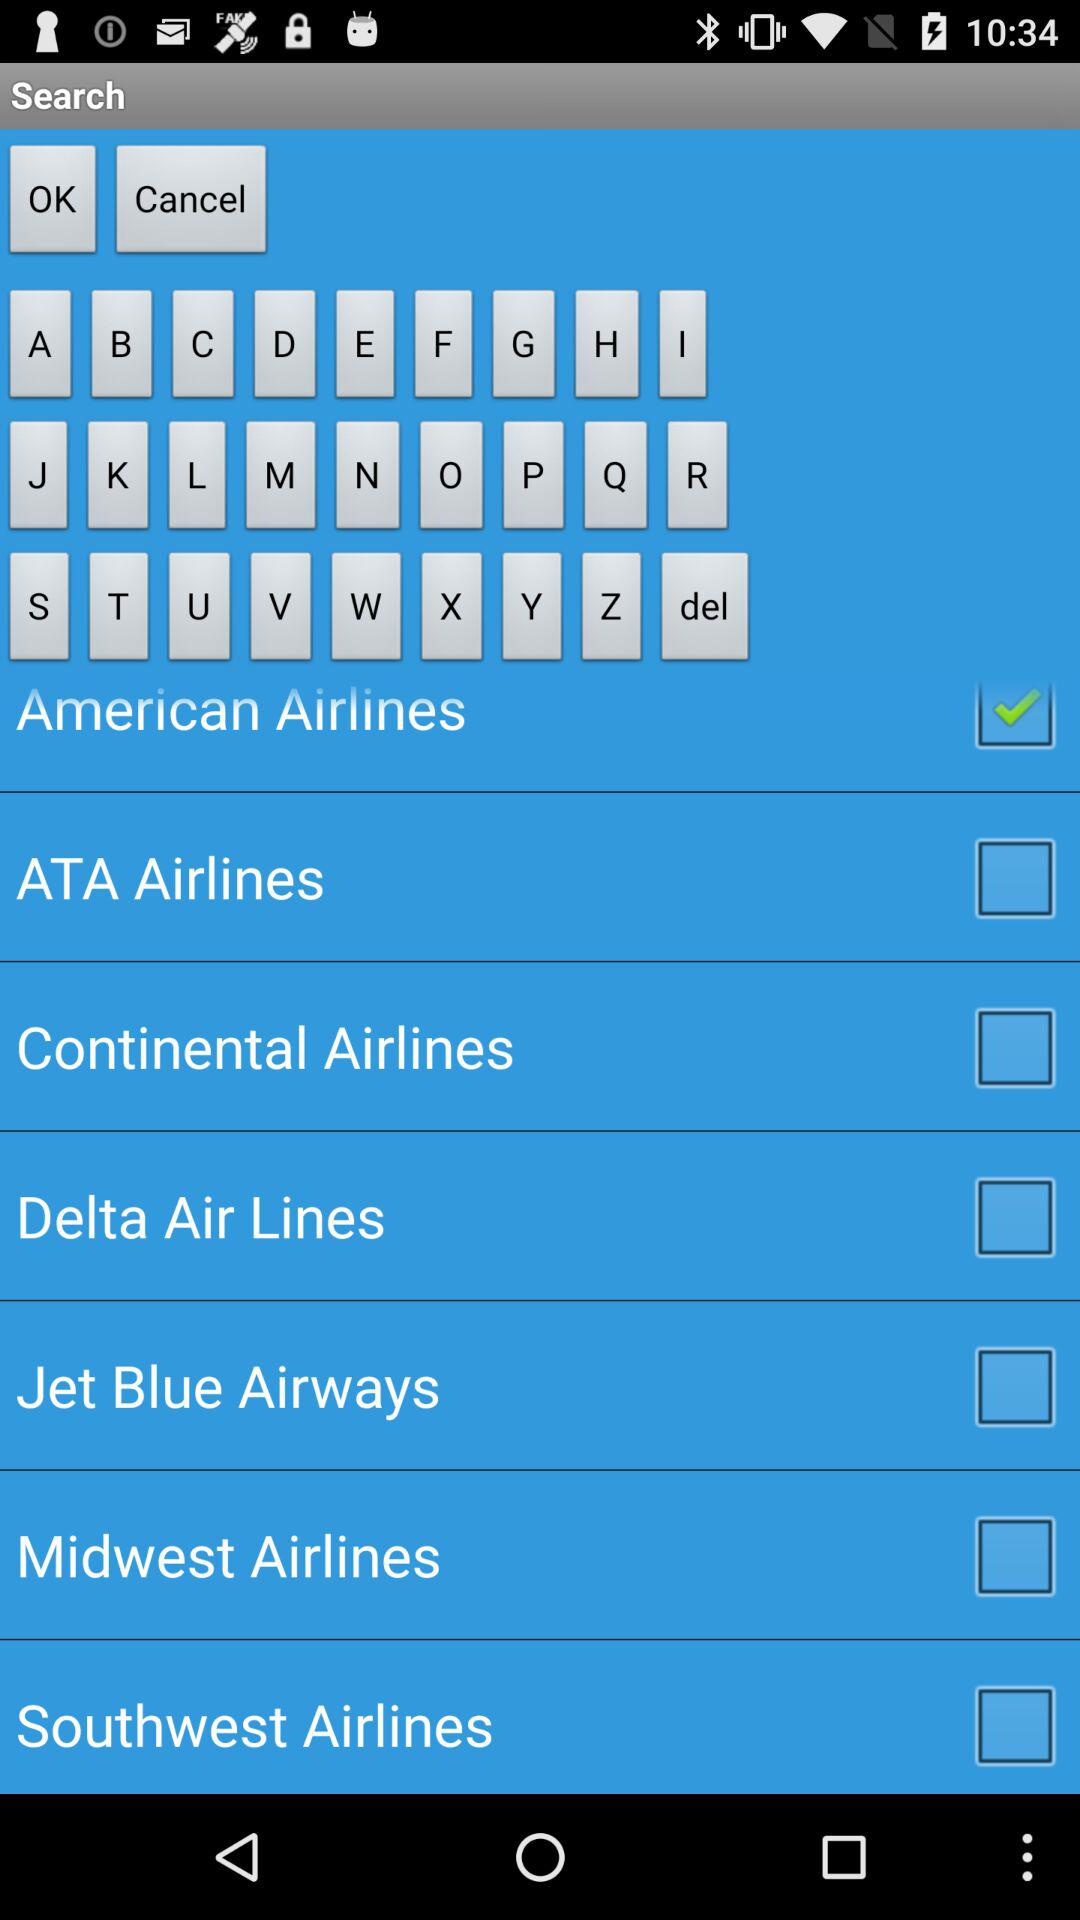What's the selected airline option? The selected airline option is "American Airlines". 